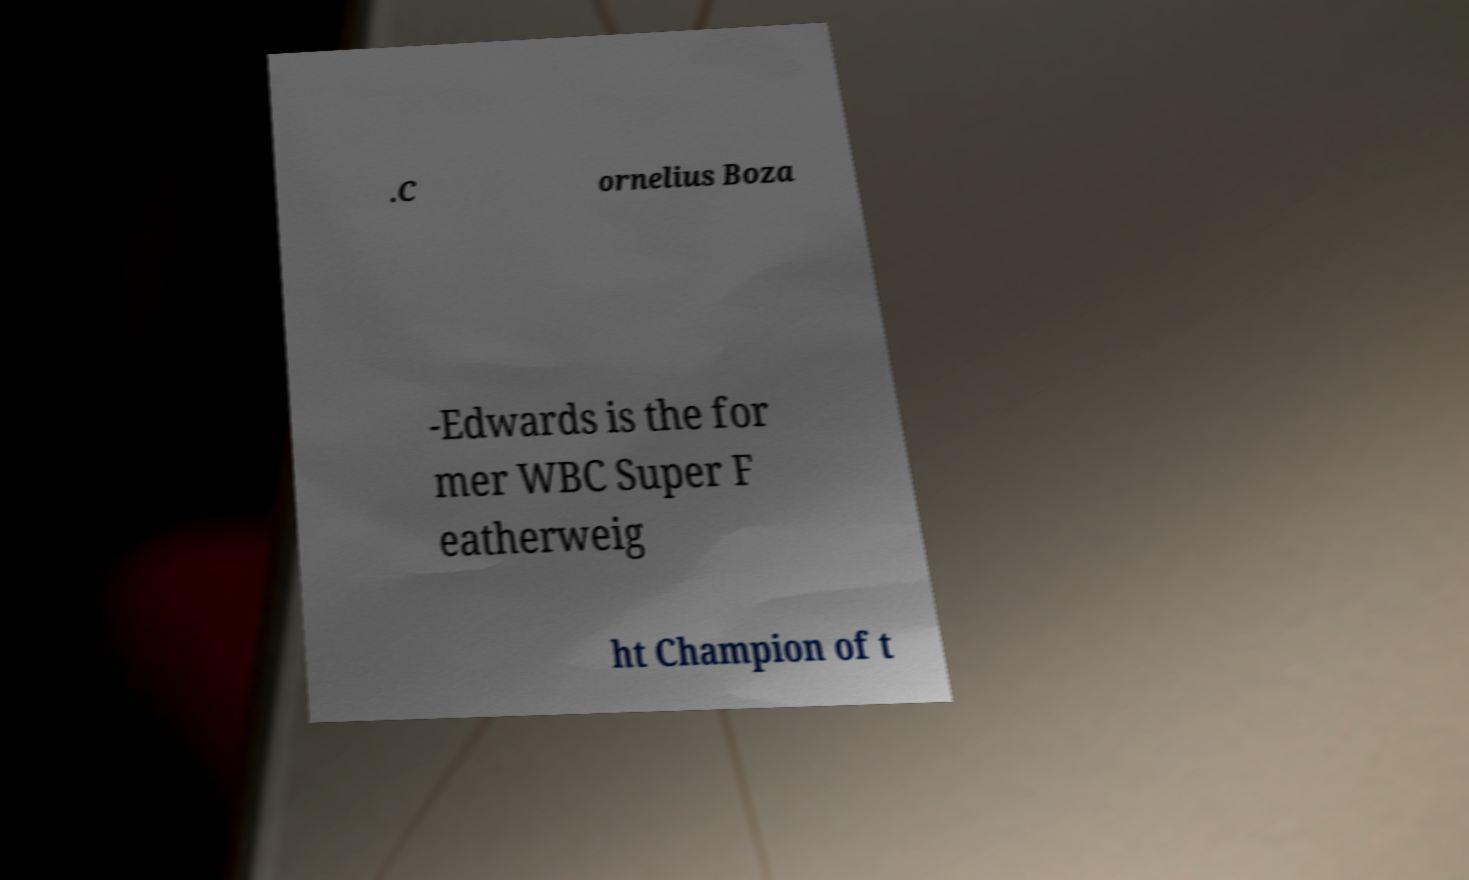Can you read and provide the text displayed in the image?This photo seems to have some interesting text. Can you extract and type it out for me? .C ornelius Boza -Edwards is the for mer WBC Super F eatherweig ht Champion of t 